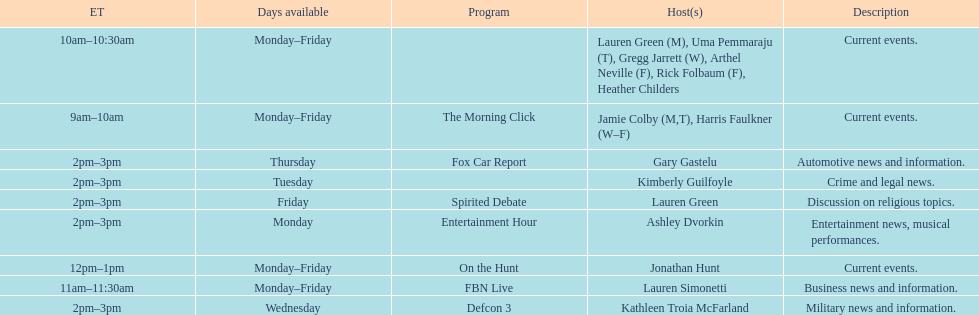Tell me the number of shows that only have one host per day. 7. 